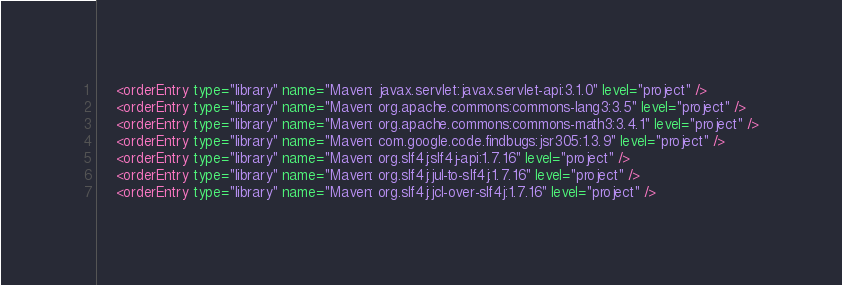<code> <loc_0><loc_0><loc_500><loc_500><_XML_>    <orderEntry type="library" name="Maven: javax.servlet:javax.servlet-api:3.1.0" level="project" />
    <orderEntry type="library" name="Maven: org.apache.commons:commons-lang3:3.5" level="project" />
    <orderEntry type="library" name="Maven: org.apache.commons:commons-math3:3.4.1" level="project" />
    <orderEntry type="library" name="Maven: com.google.code.findbugs:jsr305:1.3.9" level="project" />
    <orderEntry type="library" name="Maven: org.slf4j:slf4j-api:1.7.16" level="project" />
    <orderEntry type="library" name="Maven: org.slf4j:jul-to-slf4j:1.7.16" level="project" />
    <orderEntry type="library" name="Maven: org.slf4j:jcl-over-slf4j:1.7.16" level="project" /></code> 